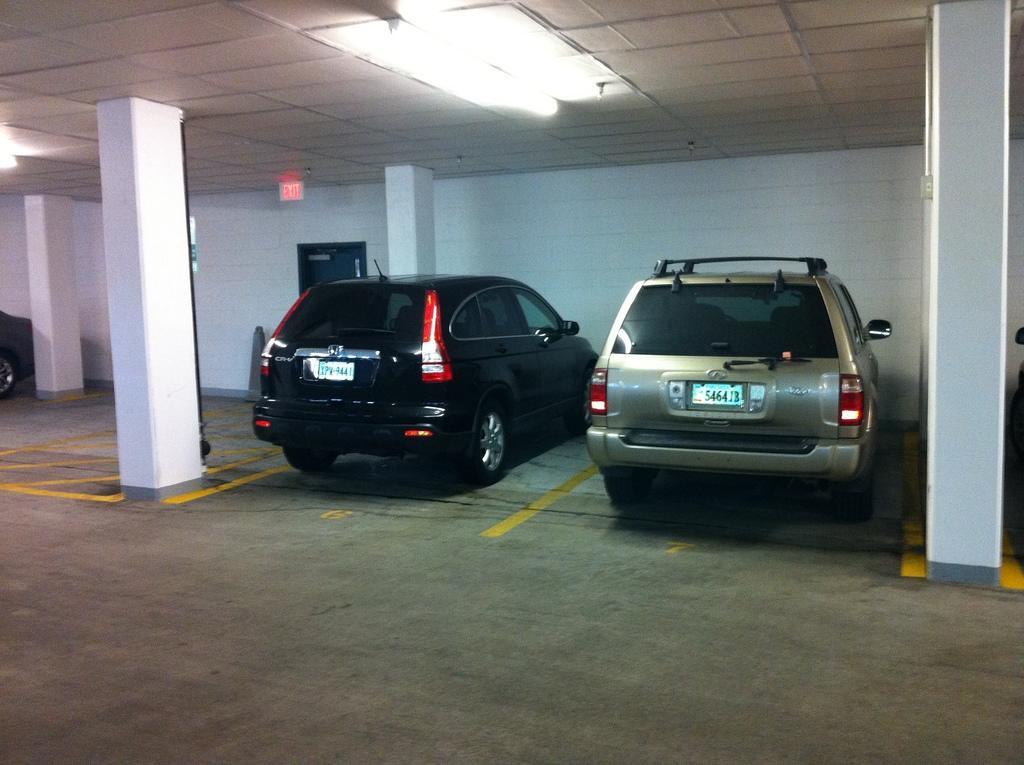In one or two sentences, can you explain what this image depicts? In this image there are two cars which are parked in the cellar. At the top there are lights. There are two pillars on either side of the cars. 